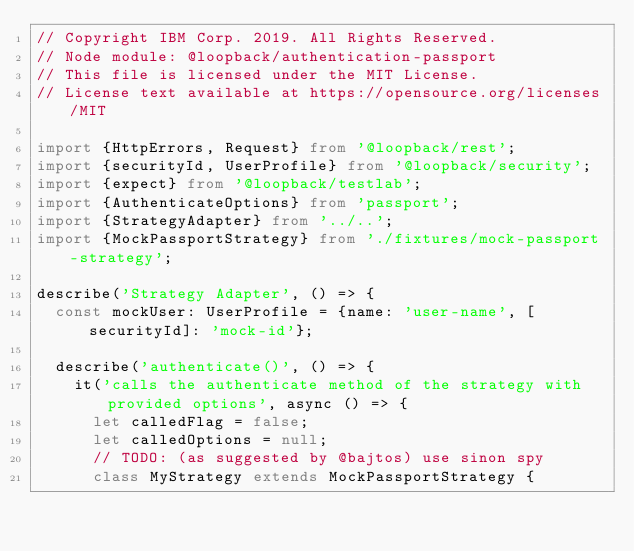<code> <loc_0><loc_0><loc_500><loc_500><_TypeScript_>// Copyright IBM Corp. 2019. All Rights Reserved.
// Node module: @loopback/authentication-passport
// This file is licensed under the MIT License.
// License text available at https://opensource.org/licenses/MIT

import {HttpErrors, Request} from '@loopback/rest';
import {securityId, UserProfile} from '@loopback/security';
import {expect} from '@loopback/testlab';
import {AuthenticateOptions} from 'passport';
import {StrategyAdapter} from '../..';
import {MockPassportStrategy} from './fixtures/mock-passport-strategy';

describe('Strategy Adapter', () => {
  const mockUser: UserProfile = {name: 'user-name', [securityId]: 'mock-id'};

  describe('authenticate()', () => {
    it('calls the authenticate method of the strategy with provided options', async () => {
      let calledFlag = false;
      let calledOptions = null;
      // TODO: (as suggested by @bajtos) use sinon spy
      class MyStrategy extends MockPassportStrategy {</code> 